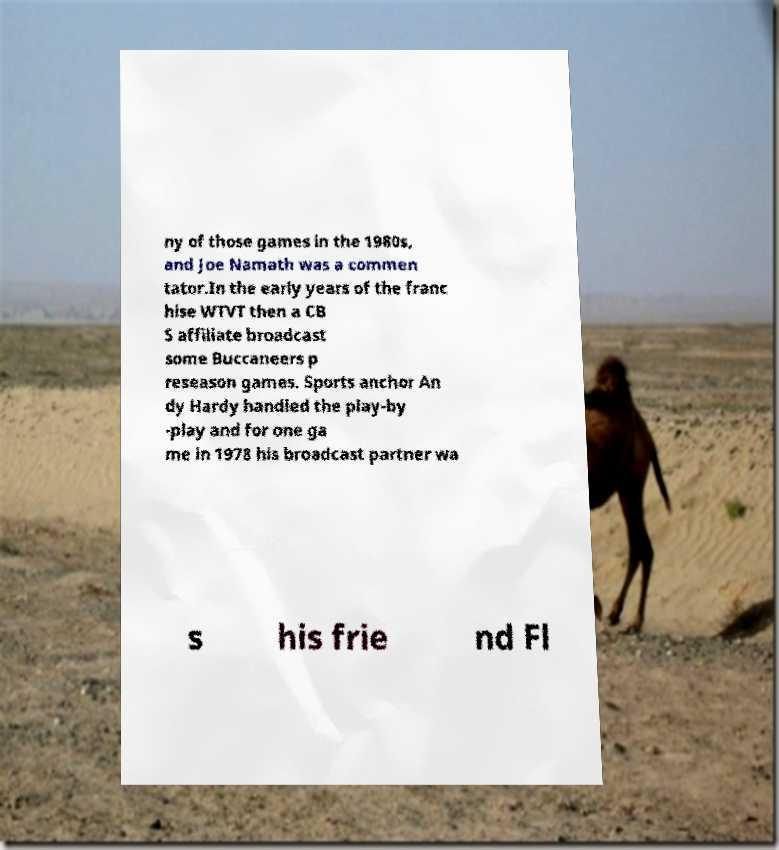There's text embedded in this image that I need extracted. Can you transcribe it verbatim? ny of those games in the 1980s, and Joe Namath was a commen tator.In the early years of the franc hise WTVT then a CB S affiliate broadcast some Buccaneers p reseason games. Sports anchor An dy Hardy handled the play-by -play and for one ga me in 1978 his broadcast partner wa s his frie nd Fl 